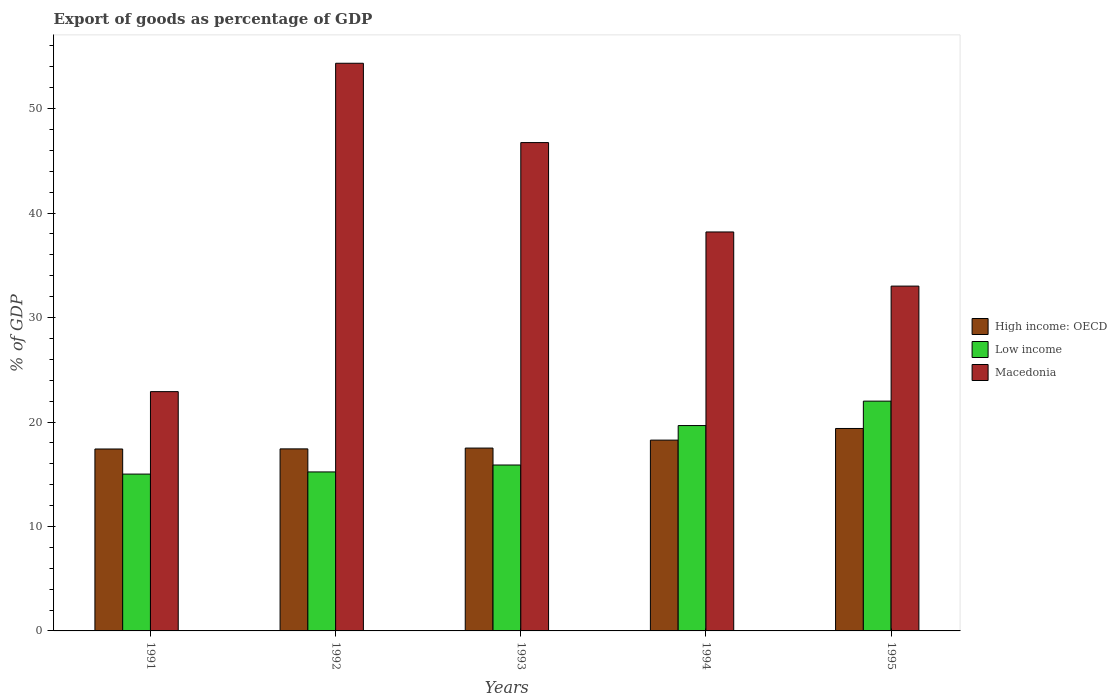How many groups of bars are there?
Your answer should be very brief. 5. Are the number of bars on each tick of the X-axis equal?
Your answer should be compact. Yes. How many bars are there on the 1st tick from the right?
Keep it short and to the point. 3. In how many cases, is the number of bars for a given year not equal to the number of legend labels?
Provide a succinct answer. 0. What is the export of goods as percentage of GDP in Low income in 1991?
Your response must be concise. 15.01. Across all years, what is the maximum export of goods as percentage of GDP in Low income?
Offer a terse response. 22. Across all years, what is the minimum export of goods as percentage of GDP in High income: OECD?
Offer a very short reply. 17.42. In which year was the export of goods as percentage of GDP in High income: OECD maximum?
Your response must be concise. 1995. What is the total export of goods as percentage of GDP in High income: OECD in the graph?
Offer a very short reply. 90. What is the difference between the export of goods as percentage of GDP in Low income in 1991 and that in 1995?
Offer a very short reply. -6.98. What is the difference between the export of goods as percentage of GDP in High income: OECD in 1992 and the export of goods as percentage of GDP in Low income in 1991?
Offer a very short reply. 2.41. What is the average export of goods as percentage of GDP in Low income per year?
Provide a succinct answer. 17.56. In the year 1993, what is the difference between the export of goods as percentage of GDP in High income: OECD and export of goods as percentage of GDP in Low income?
Your answer should be very brief. 1.62. In how many years, is the export of goods as percentage of GDP in High income: OECD greater than 44 %?
Ensure brevity in your answer.  0. What is the ratio of the export of goods as percentage of GDP in Macedonia in 1993 to that in 1994?
Your answer should be compact. 1.22. Is the difference between the export of goods as percentage of GDP in High income: OECD in 1993 and 1995 greater than the difference between the export of goods as percentage of GDP in Low income in 1993 and 1995?
Keep it short and to the point. Yes. What is the difference between the highest and the second highest export of goods as percentage of GDP in Low income?
Make the answer very short. 2.34. What is the difference between the highest and the lowest export of goods as percentage of GDP in High income: OECD?
Your answer should be very brief. 1.96. What does the 1st bar from the left in 1994 represents?
Keep it short and to the point. High income: OECD. What does the 3rd bar from the right in 1992 represents?
Provide a short and direct response. High income: OECD. Is it the case that in every year, the sum of the export of goods as percentage of GDP in Macedonia and export of goods as percentage of GDP in High income: OECD is greater than the export of goods as percentage of GDP in Low income?
Provide a succinct answer. Yes. What is the difference between two consecutive major ticks on the Y-axis?
Provide a succinct answer. 10. Are the values on the major ticks of Y-axis written in scientific E-notation?
Your answer should be very brief. No. Does the graph contain any zero values?
Offer a terse response. No. Where does the legend appear in the graph?
Provide a short and direct response. Center right. How many legend labels are there?
Provide a succinct answer. 3. How are the legend labels stacked?
Ensure brevity in your answer.  Vertical. What is the title of the graph?
Provide a succinct answer. Export of goods as percentage of GDP. What is the label or title of the Y-axis?
Your response must be concise. % of GDP. What is the % of GDP in High income: OECD in 1991?
Provide a short and direct response. 17.42. What is the % of GDP in Low income in 1991?
Offer a very short reply. 15.01. What is the % of GDP of Macedonia in 1991?
Make the answer very short. 22.91. What is the % of GDP in High income: OECD in 1992?
Ensure brevity in your answer.  17.43. What is the % of GDP of Low income in 1992?
Give a very brief answer. 15.22. What is the % of GDP in Macedonia in 1992?
Your answer should be compact. 54.35. What is the % of GDP of High income: OECD in 1993?
Offer a terse response. 17.5. What is the % of GDP in Low income in 1993?
Make the answer very short. 15.88. What is the % of GDP in Macedonia in 1993?
Your answer should be very brief. 46.75. What is the % of GDP of High income: OECD in 1994?
Provide a succinct answer. 18.27. What is the % of GDP of Low income in 1994?
Your answer should be compact. 19.66. What is the % of GDP in Macedonia in 1994?
Make the answer very short. 38.19. What is the % of GDP in High income: OECD in 1995?
Offer a terse response. 19.38. What is the % of GDP in Low income in 1995?
Give a very brief answer. 22. What is the % of GDP of Macedonia in 1995?
Keep it short and to the point. 33.01. Across all years, what is the maximum % of GDP in High income: OECD?
Make the answer very short. 19.38. Across all years, what is the maximum % of GDP of Low income?
Ensure brevity in your answer.  22. Across all years, what is the maximum % of GDP of Macedonia?
Your answer should be very brief. 54.35. Across all years, what is the minimum % of GDP in High income: OECD?
Provide a short and direct response. 17.42. Across all years, what is the minimum % of GDP of Low income?
Keep it short and to the point. 15.01. Across all years, what is the minimum % of GDP in Macedonia?
Your answer should be compact. 22.91. What is the total % of GDP of High income: OECD in the graph?
Ensure brevity in your answer.  90. What is the total % of GDP in Low income in the graph?
Ensure brevity in your answer.  87.78. What is the total % of GDP in Macedonia in the graph?
Offer a terse response. 195.21. What is the difference between the % of GDP in High income: OECD in 1991 and that in 1992?
Ensure brevity in your answer.  -0.01. What is the difference between the % of GDP in Low income in 1991 and that in 1992?
Provide a short and direct response. -0.21. What is the difference between the % of GDP of Macedonia in 1991 and that in 1992?
Give a very brief answer. -31.44. What is the difference between the % of GDP of High income: OECD in 1991 and that in 1993?
Give a very brief answer. -0.09. What is the difference between the % of GDP of Low income in 1991 and that in 1993?
Offer a very short reply. -0.87. What is the difference between the % of GDP of Macedonia in 1991 and that in 1993?
Give a very brief answer. -23.84. What is the difference between the % of GDP of High income: OECD in 1991 and that in 1994?
Ensure brevity in your answer.  -0.85. What is the difference between the % of GDP in Low income in 1991 and that in 1994?
Offer a very short reply. -4.65. What is the difference between the % of GDP of Macedonia in 1991 and that in 1994?
Ensure brevity in your answer.  -15.29. What is the difference between the % of GDP in High income: OECD in 1991 and that in 1995?
Give a very brief answer. -1.96. What is the difference between the % of GDP in Low income in 1991 and that in 1995?
Your answer should be very brief. -6.98. What is the difference between the % of GDP in Macedonia in 1991 and that in 1995?
Provide a short and direct response. -10.1. What is the difference between the % of GDP in High income: OECD in 1992 and that in 1993?
Make the answer very short. -0.08. What is the difference between the % of GDP in Low income in 1992 and that in 1993?
Provide a succinct answer. -0.66. What is the difference between the % of GDP in Macedonia in 1992 and that in 1993?
Give a very brief answer. 7.6. What is the difference between the % of GDP of High income: OECD in 1992 and that in 1994?
Offer a very short reply. -0.84. What is the difference between the % of GDP in Low income in 1992 and that in 1994?
Your answer should be very brief. -4.44. What is the difference between the % of GDP of Macedonia in 1992 and that in 1994?
Your answer should be compact. 16.15. What is the difference between the % of GDP of High income: OECD in 1992 and that in 1995?
Offer a terse response. -1.95. What is the difference between the % of GDP of Low income in 1992 and that in 1995?
Your response must be concise. -6.78. What is the difference between the % of GDP in Macedonia in 1992 and that in 1995?
Offer a terse response. 21.33. What is the difference between the % of GDP of High income: OECD in 1993 and that in 1994?
Make the answer very short. -0.76. What is the difference between the % of GDP in Low income in 1993 and that in 1994?
Offer a terse response. -3.78. What is the difference between the % of GDP in Macedonia in 1993 and that in 1994?
Give a very brief answer. 8.56. What is the difference between the % of GDP in High income: OECD in 1993 and that in 1995?
Your response must be concise. -1.88. What is the difference between the % of GDP in Low income in 1993 and that in 1995?
Provide a short and direct response. -6.11. What is the difference between the % of GDP in Macedonia in 1993 and that in 1995?
Make the answer very short. 13.74. What is the difference between the % of GDP of High income: OECD in 1994 and that in 1995?
Ensure brevity in your answer.  -1.11. What is the difference between the % of GDP of Low income in 1994 and that in 1995?
Give a very brief answer. -2.34. What is the difference between the % of GDP of Macedonia in 1994 and that in 1995?
Offer a terse response. 5.18. What is the difference between the % of GDP of High income: OECD in 1991 and the % of GDP of Low income in 1992?
Your response must be concise. 2.2. What is the difference between the % of GDP in High income: OECD in 1991 and the % of GDP in Macedonia in 1992?
Offer a very short reply. -36.93. What is the difference between the % of GDP in Low income in 1991 and the % of GDP in Macedonia in 1992?
Offer a terse response. -39.33. What is the difference between the % of GDP in High income: OECD in 1991 and the % of GDP in Low income in 1993?
Your response must be concise. 1.53. What is the difference between the % of GDP of High income: OECD in 1991 and the % of GDP of Macedonia in 1993?
Give a very brief answer. -29.33. What is the difference between the % of GDP of Low income in 1991 and the % of GDP of Macedonia in 1993?
Offer a terse response. -31.74. What is the difference between the % of GDP in High income: OECD in 1991 and the % of GDP in Low income in 1994?
Your answer should be very brief. -2.24. What is the difference between the % of GDP of High income: OECD in 1991 and the % of GDP of Macedonia in 1994?
Make the answer very short. -20.78. What is the difference between the % of GDP in Low income in 1991 and the % of GDP in Macedonia in 1994?
Your answer should be very brief. -23.18. What is the difference between the % of GDP of High income: OECD in 1991 and the % of GDP of Low income in 1995?
Ensure brevity in your answer.  -4.58. What is the difference between the % of GDP in High income: OECD in 1991 and the % of GDP in Macedonia in 1995?
Offer a very short reply. -15.59. What is the difference between the % of GDP of Low income in 1991 and the % of GDP of Macedonia in 1995?
Ensure brevity in your answer.  -18. What is the difference between the % of GDP in High income: OECD in 1992 and the % of GDP in Low income in 1993?
Make the answer very short. 1.54. What is the difference between the % of GDP in High income: OECD in 1992 and the % of GDP in Macedonia in 1993?
Your answer should be compact. -29.32. What is the difference between the % of GDP in Low income in 1992 and the % of GDP in Macedonia in 1993?
Give a very brief answer. -31.53. What is the difference between the % of GDP of High income: OECD in 1992 and the % of GDP of Low income in 1994?
Offer a very short reply. -2.23. What is the difference between the % of GDP of High income: OECD in 1992 and the % of GDP of Macedonia in 1994?
Your response must be concise. -20.77. What is the difference between the % of GDP in Low income in 1992 and the % of GDP in Macedonia in 1994?
Offer a terse response. -22.97. What is the difference between the % of GDP of High income: OECD in 1992 and the % of GDP of Low income in 1995?
Offer a terse response. -4.57. What is the difference between the % of GDP of High income: OECD in 1992 and the % of GDP of Macedonia in 1995?
Offer a terse response. -15.58. What is the difference between the % of GDP in Low income in 1992 and the % of GDP in Macedonia in 1995?
Provide a short and direct response. -17.79. What is the difference between the % of GDP of High income: OECD in 1993 and the % of GDP of Low income in 1994?
Ensure brevity in your answer.  -2.16. What is the difference between the % of GDP in High income: OECD in 1993 and the % of GDP in Macedonia in 1994?
Offer a terse response. -20.69. What is the difference between the % of GDP of Low income in 1993 and the % of GDP of Macedonia in 1994?
Provide a short and direct response. -22.31. What is the difference between the % of GDP of High income: OECD in 1993 and the % of GDP of Low income in 1995?
Your response must be concise. -4.49. What is the difference between the % of GDP of High income: OECD in 1993 and the % of GDP of Macedonia in 1995?
Provide a short and direct response. -15.51. What is the difference between the % of GDP of Low income in 1993 and the % of GDP of Macedonia in 1995?
Offer a terse response. -17.13. What is the difference between the % of GDP in High income: OECD in 1994 and the % of GDP in Low income in 1995?
Your answer should be compact. -3.73. What is the difference between the % of GDP in High income: OECD in 1994 and the % of GDP in Macedonia in 1995?
Your answer should be very brief. -14.74. What is the difference between the % of GDP in Low income in 1994 and the % of GDP in Macedonia in 1995?
Offer a terse response. -13.35. What is the average % of GDP in High income: OECD per year?
Your answer should be compact. 18. What is the average % of GDP in Low income per year?
Offer a very short reply. 17.56. What is the average % of GDP of Macedonia per year?
Make the answer very short. 39.04. In the year 1991, what is the difference between the % of GDP of High income: OECD and % of GDP of Low income?
Your answer should be compact. 2.4. In the year 1991, what is the difference between the % of GDP in High income: OECD and % of GDP in Macedonia?
Provide a succinct answer. -5.49. In the year 1991, what is the difference between the % of GDP of Low income and % of GDP of Macedonia?
Keep it short and to the point. -7.89. In the year 1992, what is the difference between the % of GDP of High income: OECD and % of GDP of Low income?
Provide a short and direct response. 2.21. In the year 1992, what is the difference between the % of GDP of High income: OECD and % of GDP of Macedonia?
Your answer should be very brief. -36.92. In the year 1992, what is the difference between the % of GDP of Low income and % of GDP of Macedonia?
Make the answer very short. -39.12. In the year 1993, what is the difference between the % of GDP in High income: OECD and % of GDP in Low income?
Your response must be concise. 1.62. In the year 1993, what is the difference between the % of GDP in High income: OECD and % of GDP in Macedonia?
Offer a very short reply. -29.25. In the year 1993, what is the difference between the % of GDP of Low income and % of GDP of Macedonia?
Provide a short and direct response. -30.87. In the year 1994, what is the difference between the % of GDP in High income: OECD and % of GDP in Low income?
Make the answer very short. -1.39. In the year 1994, what is the difference between the % of GDP in High income: OECD and % of GDP in Macedonia?
Offer a terse response. -19.93. In the year 1994, what is the difference between the % of GDP in Low income and % of GDP in Macedonia?
Give a very brief answer. -18.53. In the year 1995, what is the difference between the % of GDP of High income: OECD and % of GDP of Low income?
Give a very brief answer. -2.62. In the year 1995, what is the difference between the % of GDP of High income: OECD and % of GDP of Macedonia?
Provide a short and direct response. -13.63. In the year 1995, what is the difference between the % of GDP in Low income and % of GDP in Macedonia?
Your response must be concise. -11.01. What is the ratio of the % of GDP of High income: OECD in 1991 to that in 1992?
Your answer should be compact. 1. What is the ratio of the % of GDP in Low income in 1991 to that in 1992?
Provide a short and direct response. 0.99. What is the ratio of the % of GDP in Macedonia in 1991 to that in 1992?
Ensure brevity in your answer.  0.42. What is the ratio of the % of GDP in High income: OECD in 1991 to that in 1993?
Give a very brief answer. 0.99. What is the ratio of the % of GDP in Low income in 1991 to that in 1993?
Ensure brevity in your answer.  0.95. What is the ratio of the % of GDP of Macedonia in 1991 to that in 1993?
Ensure brevity in your answer.  0.49. What is the ratio of the % of GDP in High income: OECD in 1991 to that in 1994?
Provide a short and direct response. 0.95. What is the ratio of the % of GDP in Low income in 1991 to that in 1994?
Provide a short and direct response. 0.76. What is the ratio of the % of GDP in Macedonia in 1991 to that in 1994?
Keep it short and to the point. 0.6. What is the ratio of the % of GDP of High income: OECD in 1991 to that in 1995?
Offer a terse response. 0.9. What is the ratio of the % of GDP in Low income in 1991 to that in 1995?
Your response must be concise. 0.68. What is the ratio of the % of GDP in Macedonia in 1991 to that in 1995?
Ensure brevity in your answer.  0.69. What is the ratio of the % of GDP of High income: OECD in 1992 to that in 1993?
Make the answer very short. 1. What is the ratio of the % of GDP of Low income in 1992 to that in 1993?
Provide a succinct answer. 0.96. What is the ratio of the % of GDP in Macedonia in 1992 to that in 1993?
Your response must be concise. 1.16. What is the ratio of the % of GDP in High income: OECD in 1992 to that in 1994?
Offer a terse response. 0.95. What is the ratio of the % of GDP in Low income in 1992 to that in 1994?
Provide a short and direct response. 0.77. What is the ratio of the % of GDP of Macedonia in 1992 to that in 1994?
Your response must be concise. 1.42. What is the ratio of the % of GDP in High income: OECD in 1992 to that in 1995?
Provide a short and direct response. 0.9. What is the ratio of the % of GDP of Low income in 1992 to that in 1995?
Your answer should be very brief. 0.69. What is the ratio of the % of GDP in Macedonia in 1992 to that in 1995?
Ensure brevity in your answer.  1.65. What is the ratio of the % of GDP of High income: OECD in 1993 to that in 1994?
Provide a short and direct response. 0.96. What is the ratio of the % of GDP in Low income in 1993 to that in 1994?
Make the answer very short. 0.81. What is the ratio of the % of GDP of Macedonia in 1993 to that in 1994?
Ensure brevity in your answer.  1.22. What is the ratio of the % of GDP in High income: OECD in 1993 to that in 1995?
Provide a short and direct response. 0.9. What is the ratio of the % of GDP of Low income in 1993 to that in 1995?
Provide a succinct answer. 0.72. What is the ratio of the % of GDP in Macedonia in 1993 to that in 1995?
Keep it short and to the point. 1.42. What is the ratio of the % of GDP in High income: OECD in 1994 to that in 1995?
Ensure brevity in your answer.  0.94. What is the ratio of the % of GDP of Low income in 1994 to that in 1995?
Your response must be concise. 0.89. What is the ratio of the % of GDP in Macedonia in 1994 to that in 1995?
Keep it short and to the point. 1.16. What is the difference between the highest and the second highest % of GDP in High income: OECD?
Your answer should be very brief. 1.11. What is the difference between the highest and the second highest % of GDP of Low income?
Give a very brief answer. 2.34. What is the difference between the highest and the second highest % of GDP of Macedonia?
Give a very brief answer. 7.6. What is the difference between the highest and the lowest % of GDP of High income: OECD?
Provide a short and direct response. 1.96. What is the difference between the highest and the lowest % of GDP of Low income?
Your answer should be compact. 6.98. What is the difference between the highest and the lowest % of GDP of Macedonia?
Your answer should be compact. 31.44. 